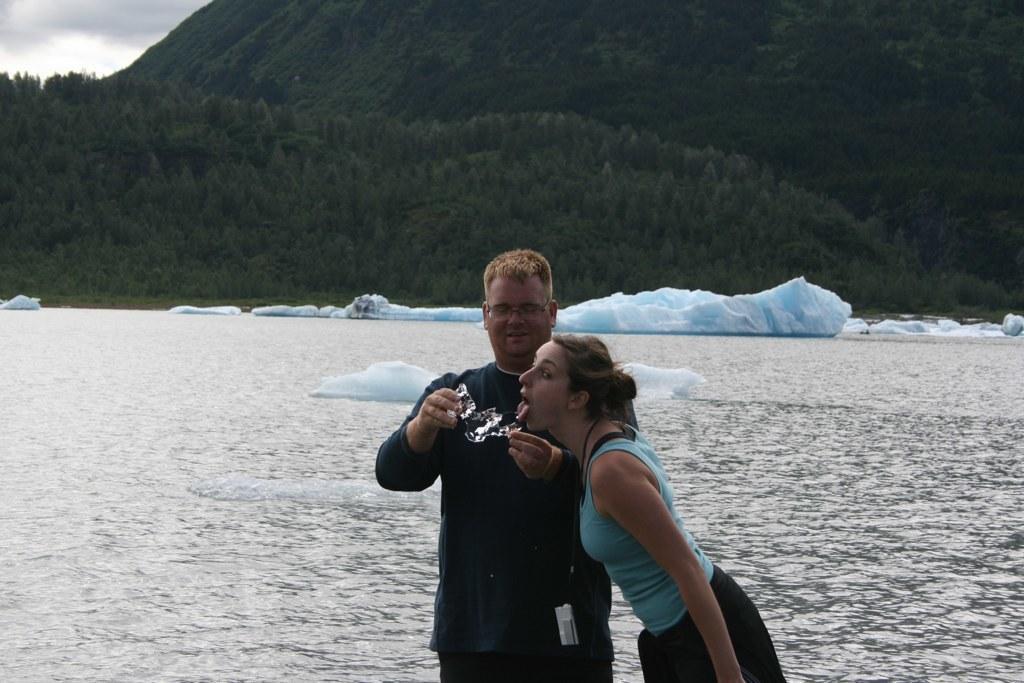How would you summarize this image in a sentence or two? In the foreground of the image there are two people. In the background of the image there are trees, sky. In the center of the image there is water with icebergs. 